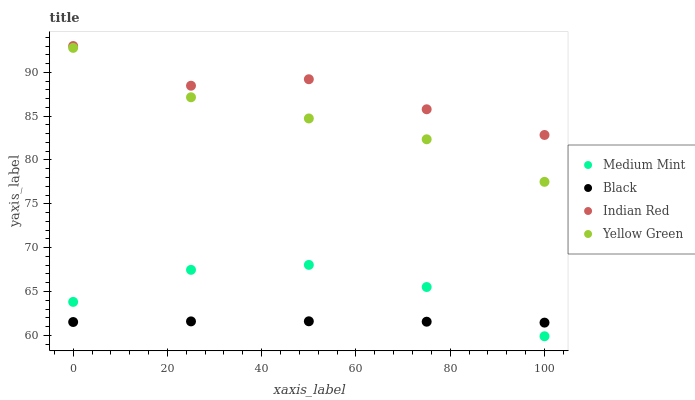Does Black have the minimum area under the curve?
Answer yes or no. Yes. Does Indian Red have the maximum area under the curve?
Answer yes or no. Yes. Does Yellow Green have the minimum area under the curve?
Answer yes or no. No. Does Yellow Green have the maximum area under the curve?
Answer yes or no. No. Is Black the smoothest?
Answer yes or no. Yes. Is Indian Red the roughest?
Answer yes or no. Yes. Is Yellow Green the smoothest?
Answer yes or no. No. Is Yellow Green the roughest?
Answer yes or no. No. Does Medium Mint have the lowest value?
Answer yes or no. Yes. Does Black have the lowest value?
Answer yes or no. No. Does Indian Red have the highest value?
Answer yes or no. Yes. Does Yellow Green have the highest value?
Answer yes or no. No. Is Medium Mint less than Indian Red?
Answer yes or no. Yes. Is Indian Red greater than Medium Mint?
Answer yes or no. Yes. Does Black intersect Medium Mint?
Answer yes or no. Yes. Is Black less than Medium Mint?
Answer yes or no. No. Is Black greater than Medium Mint?
Answer yes or no. No. Does Medium Mint intersect Indian Red?
Answer yes or no. No. 